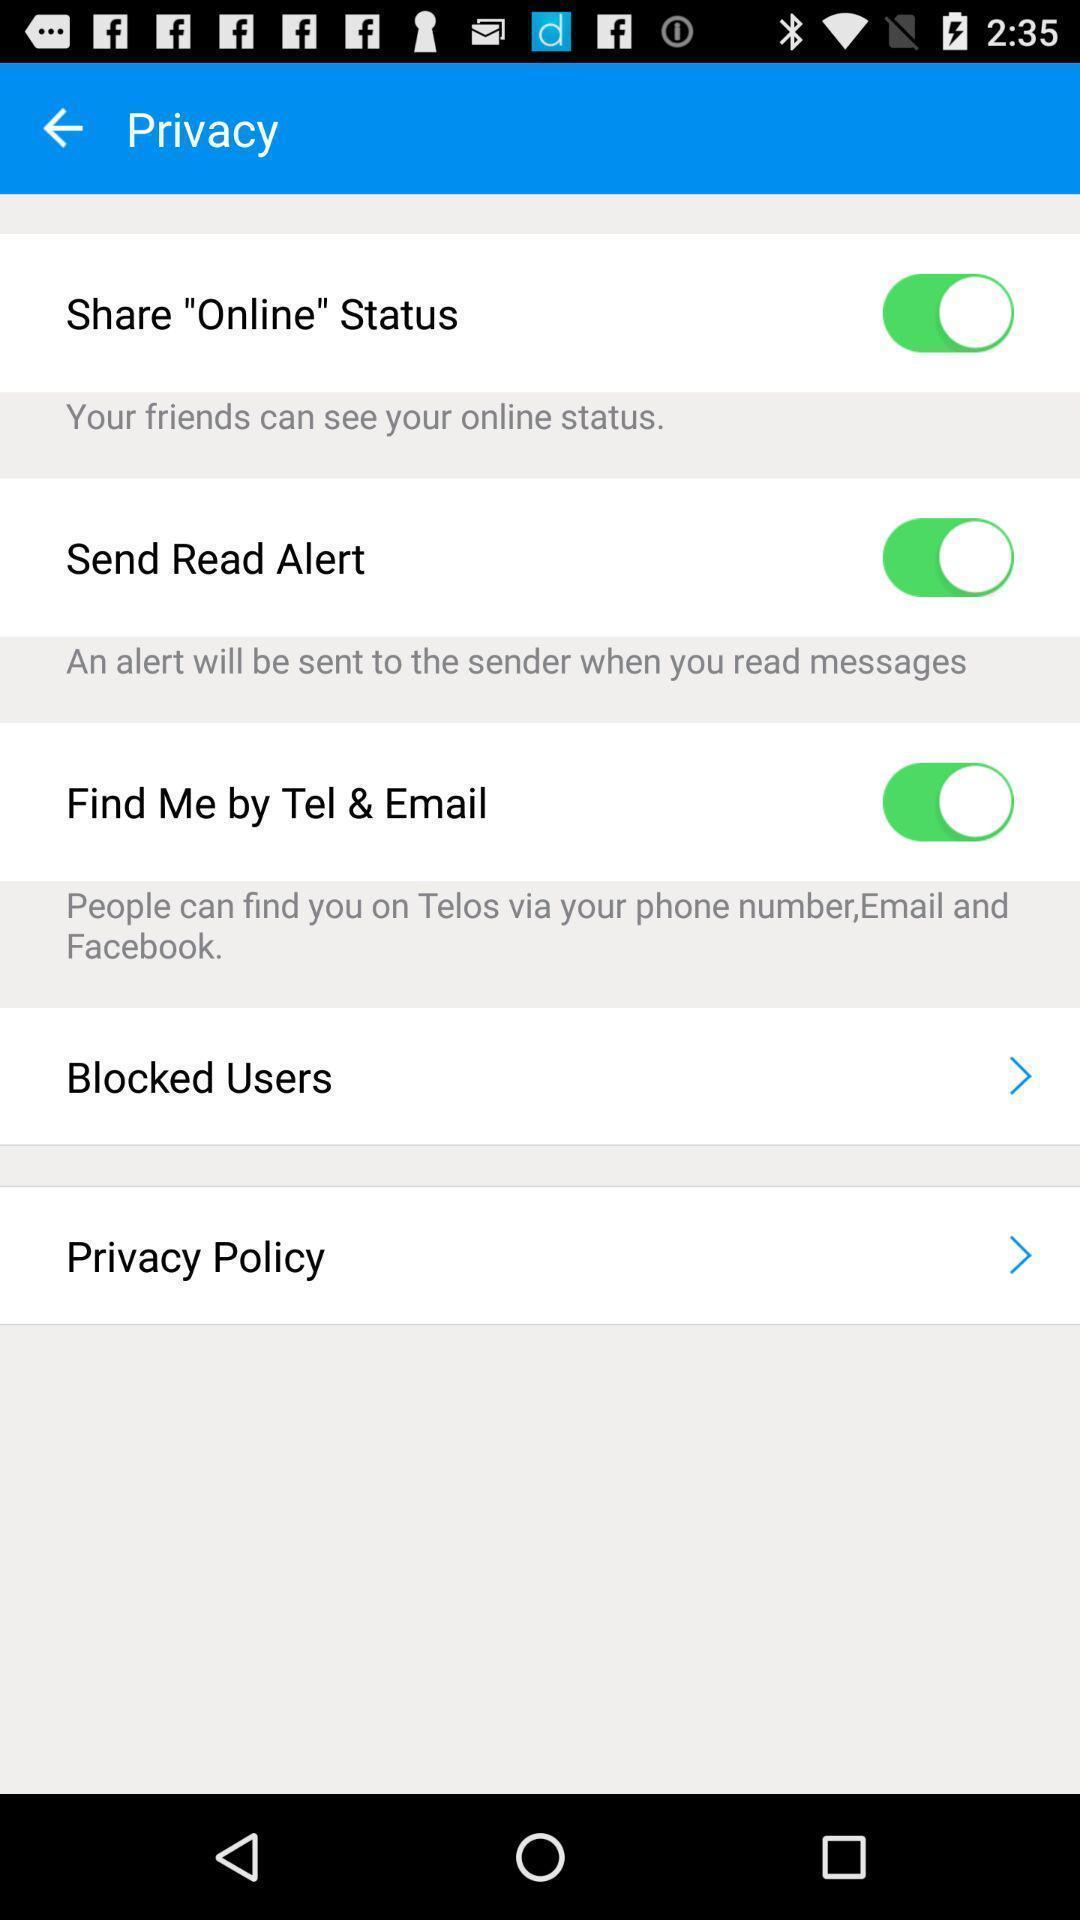What can you discern from this picture? Screen displaying multiple private setting options. 